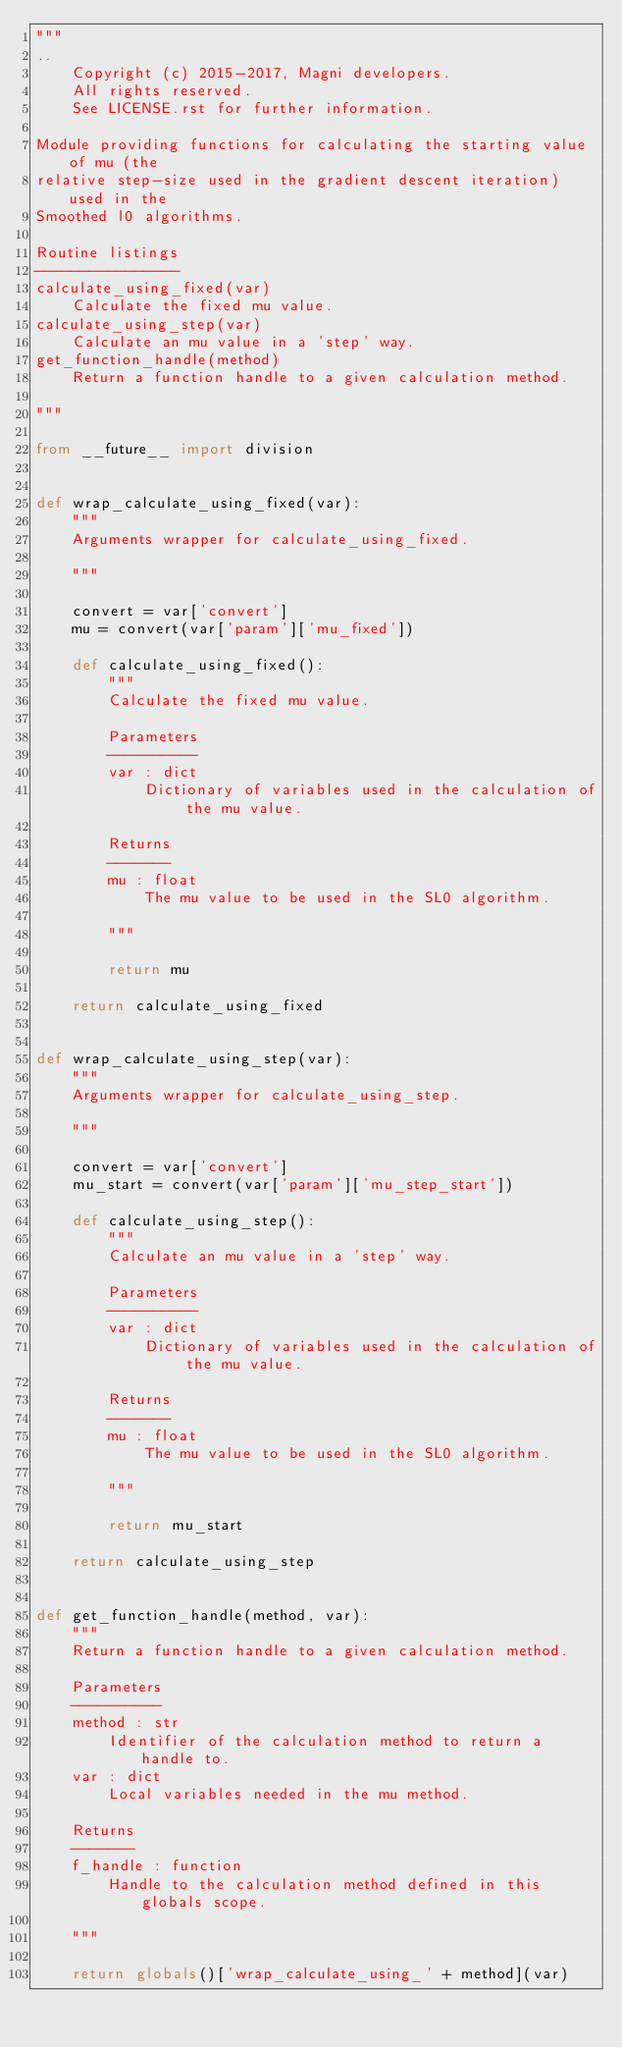<code> <loc_0><loc_0><loc_500><loc_500><_Python_>"""
..
    Copyright (c) 2015-2017, Magni developers.
    All rights reserved.
    See LICENSE.rst for further information.

Module providing functions for calculating the starting value of mu (the
relative step-size used in the gradient descent iteration)  used in the
Smoothed l0 algorithms.

Routine listings
----------------
calculate_using_fixed(var)
    Calculate the fixed mu value.
calculate_using_step(var)
    Calculate an mu value in a 'step' way.
get_function_handle(method)
    Return a function handle to a given calculation method.

"""

from __future__ import division


def wrap_calculate_using_fixed(var):
    """
    Arguments wrapper for calculate_using_fixed.

    """

    convert = var['convert']
    mu = convert(var['param']['mu_fixed'])

    def calculate_using_fixed():
        """
        Calculate the fixed mu value.

        Parameters
        ----------
        var : dict
            Dictionary of variables used in the calculation of the mu value.

        Returns
        -------
        mu : float
            The mu value to be used in the SL0 algorithm.

        """

        return mu

    return calculate_using_fixed


def wrap_calculate_using_step(var):
    """
    Arguments wrapper for calculate_using_step.

    """

    convert = var['convert']
    mu_start = convert(var['param']['mu_step_start'])

    def calculate_using_step():
        """
        Calculate an mu value in a 'step' way.

        Parameters
        ----------
        var : dict
            Dictionary of variables used in the calculation of the mu value.

        Returns
        -------
        mu : float
            The mu value to be used in the SL0 algorithm.

        """

        return mu_start

    return calculate_using_step


def get_function_handle(method, var):
    """
    Return a function handle to a given calculation method.

    Parameters
    ----------
    method : str
        Identifier of the calculation method to return a handle to.
    var : dict
        Local variables needed in the mu method.

    Returns
    -------
    f_handle : function
        Handle to the calculation method defined in this globals scope.

    """

    return globals()['wrap_calculate_using_' + method](var)
</code> 